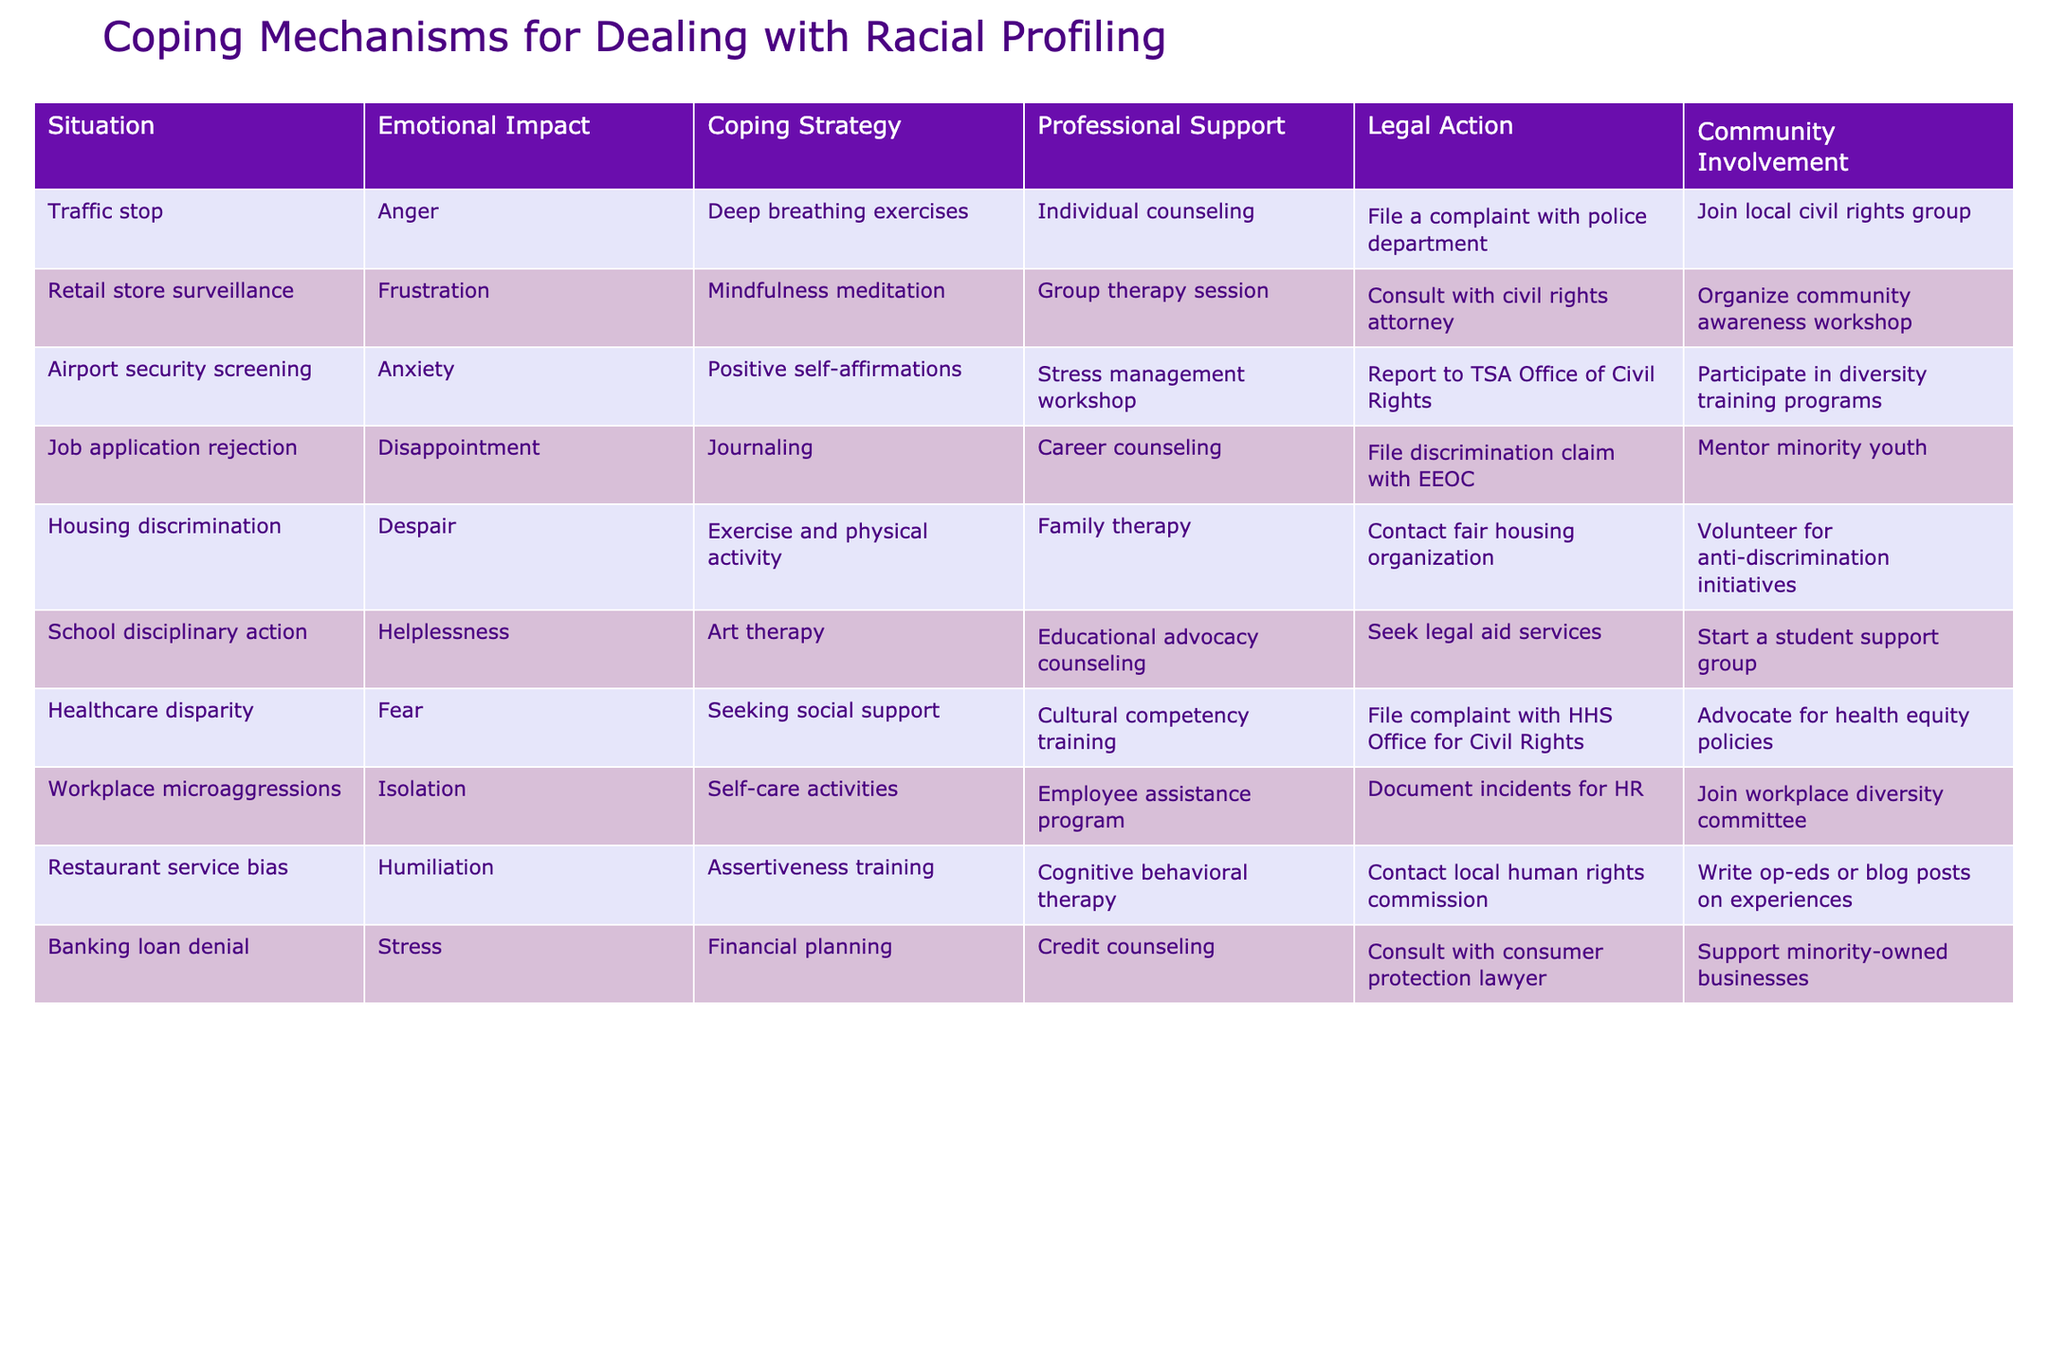What coping strategy is recommended for dealing with anxiety during airport security screening? According to the table, the coping strategy for anxiety during airport security screening is positive self-affirmations, as mentioned in that particular row under the coping strategy column.
Answer: Positive self-affirmations Which professional support option is listed for those who experience housing discrimination? From the table, the professional support option available for individuals facing housing discrimination is family therapy, which is specified in the row concerning housing discrimination under the professional support column.
Answer: Family therapy How does the coping strategy for restaurant service bias compare to that of retail store surveillance in terms of emotional impact? In the table, the emotional impact for restaurant service bias is humiliation, and for retail store surveillance, it is frustration. Thus, one can say that the emotional impact of restaurant service bias is more intense as humiliation often signifies a deeper level of emotional distress compared to frustration.
Answer: Restaurant service bias has more intense emotional impact What is the sum of the emotional impacts presented in the table for situations involving traffic stops and banking loan denials? The emotional impacts are categorized as anger for traffic stops and stress for banking loan denials. Numerically scoring emotional impacts is subjective, but one could argue on a scale of 1 to 5, anger could be rated as 4 and stress as 3. Therefore, the sum would be 4 + 3 = 7.
Answer: 7 Is exercise listed as a coping strategy for job application rejection? No, according to the table, exercise is listed as a coping strategy for housing discrimination, not job application rejection, which is associated with journaling instead.
Answer: No What community involvement action is suggested for those affected by healthcare disparity? The table indicates that individuals affected by healthcare disparity are encouraged to advocate for health equity policies as their community involvement action, reflected in the respective row.
Answer: Advocate for health equity policies If someone wants to join a local civil rights group, which situation's emotional impact are they likely trying to cope with? The table lists joining a local civil rights group under community involvement for traffic stops, indicating that individuals facing this situation might be experiencing anger. Therefore, one could infer that they are likely coping with the emotional impact of anger from traffic stops.
Answer: Anger from traffic stops Based on the table, what combination of emotional impact and coping strategy applies to workplace microaggressions? For workplace microaggressions, the emotional impact is isolation, while the suggested coping strategy is self-care activities. This reflects a situation where individuals feel isolated and are encouraged to prioritize self-care.
Answer: Isolation and self-care activities 